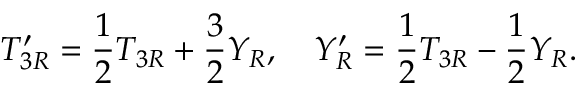<formula> <loc_0><loc_0><loc_500><loc_500>T _ { 3 R } ^ { \prime } = { \frac { 1 } { 2 } } T _ { 3 R } + { \frac { 3 } { 2 } } Y _ { R } , Y _ { R } ^ { \prime } = { \frac { 1 } { 2 } } T _ { 3 R } - { \frac { 1 } { 2 } } Y _ { R } .</formula> 